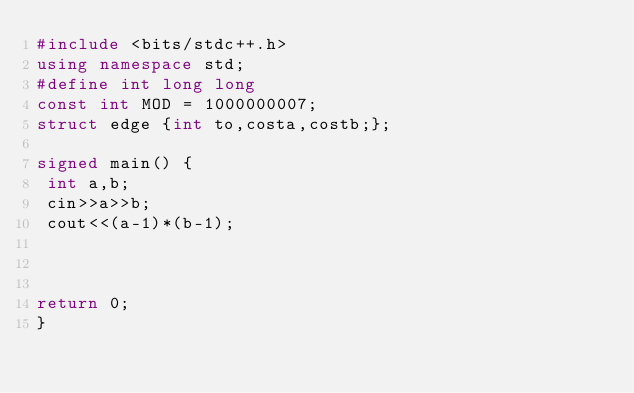<code> <loc_0><loc_0><loc_500><loc_500><_C++_>#include <bits/stdc++.h>
using namespace std;
#define int long long
const int MOD = 1000000007;
struct edge {int to,costa,costb;};

signed main() {
 int a,b;
 cin>>a>>b;
 cout<<(a-1)*(b-1);

 

return 0;
}
</code> 